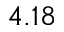Convert formula to latex. <formula><loc_0><loc_0><loc_500><loc_500>4 . 1 8</formula> 